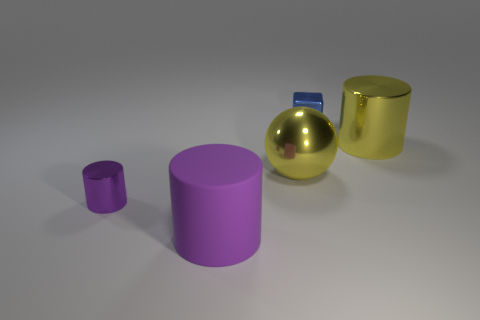Add 2 big objects. How many objects exist? 7 Subtract all cylinders. How many objects are left? 2 Subtract 0 green cubes. How many objects are left? 5 Subtract all big yellow things. Subtract all tiny purple things. How many objects are left? 2 Add 4 big metal objects. How many big metal objects are left? 6 Add 4 tiny rubber objects. How many tiny rubber objects exist? 4 